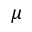Convert formula to latex. <formula><loc_0><loc_0><loc_500><loc_500>\mu</formula> 